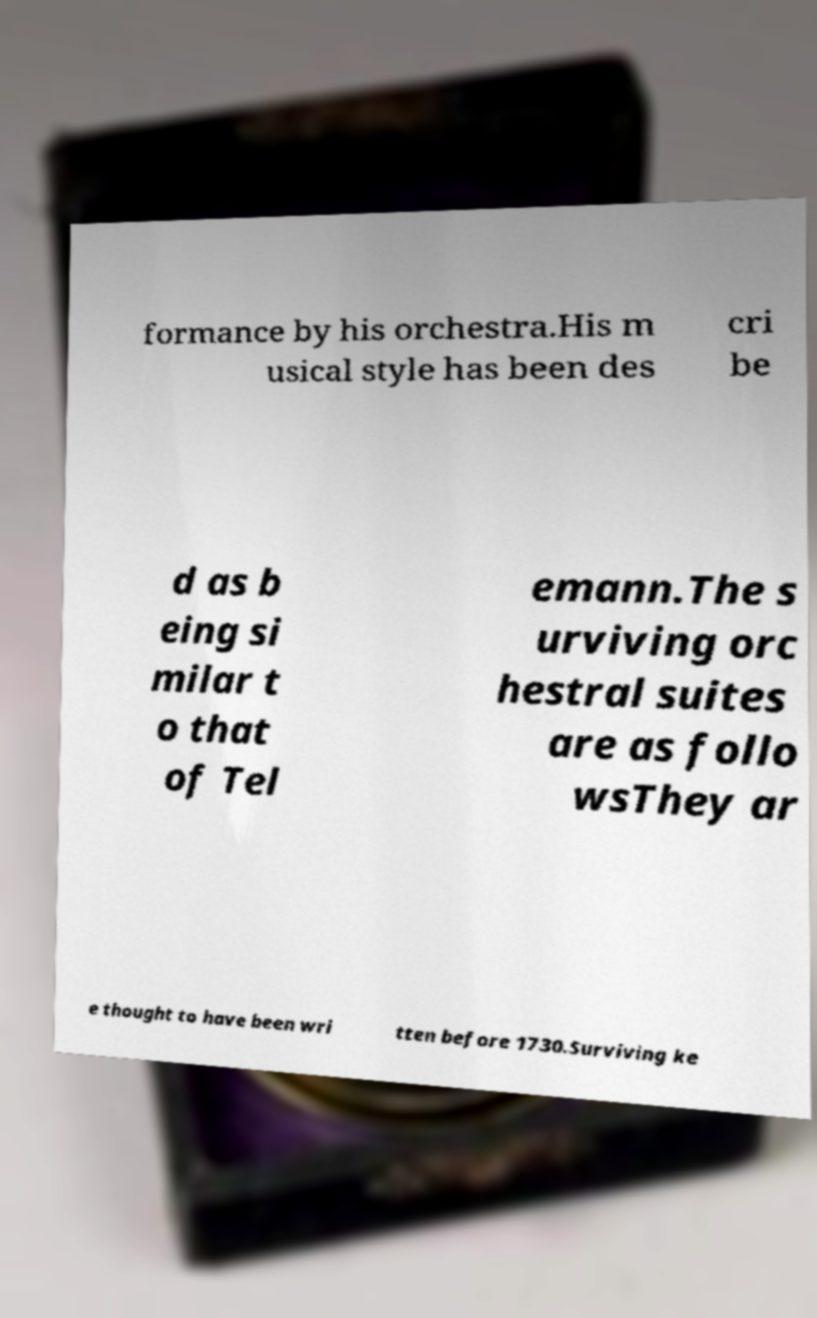Can you read and provide the text displayed in the image?This photo seems to have some interesting text. Can you extract and type it out for me? formance by his orchestra.His m usical style has been des cri be d as b eing si milar t o that of Tel emann.The s urviving orc hestral suites are as follo wsThey ar e thought to have been wri tten before 1730.Surviving ke 